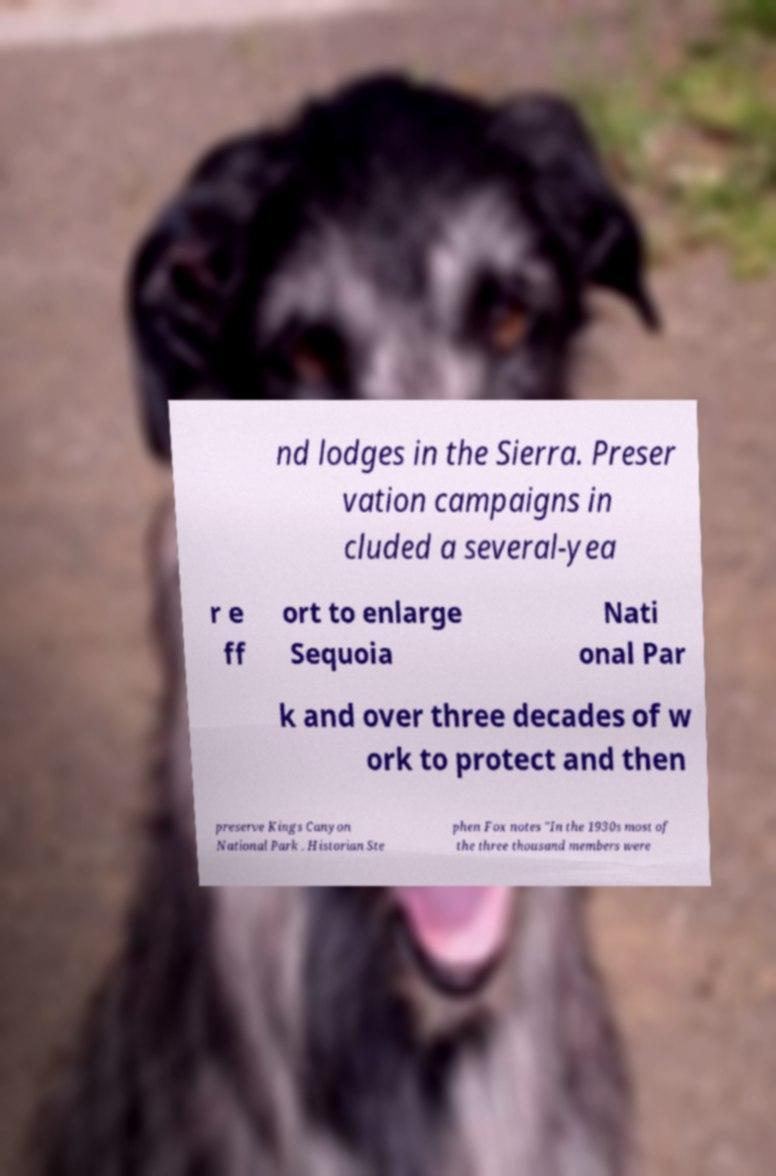Could you extract and type out the text from this image? nd lodges in the Sierra. Preser vation campaigns in cluded a several-yea r e ff ort to enlarge Sequoia Nati onal Par k and over three decades of w ork to protect and then preserve Kings Canyon National Park . Historian Ste phen Fox notes "In the 1930s most of the three thousand members were 